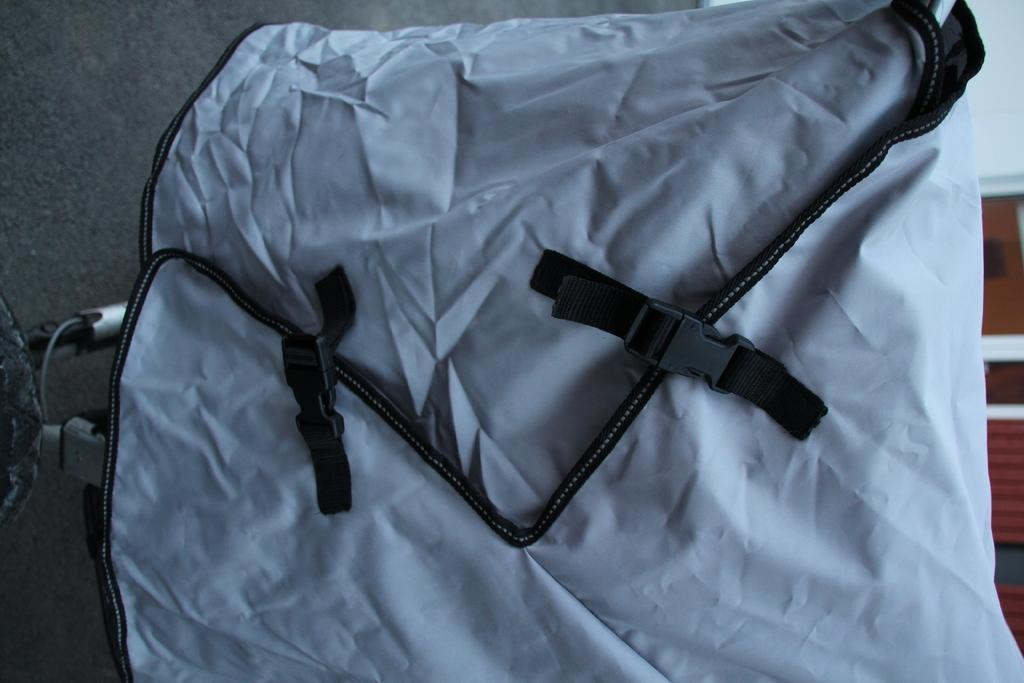What color is the bag that is visible in the image? The bag is blue in color. What type of fasteners are attached to the bag? There are two black clips on the bag. What type of country is depicted in the image? There is no country depicted in the image; it only features a blue color bag with two black clips. Are there any curtains visible in the image? There are no curtains present in the image. 